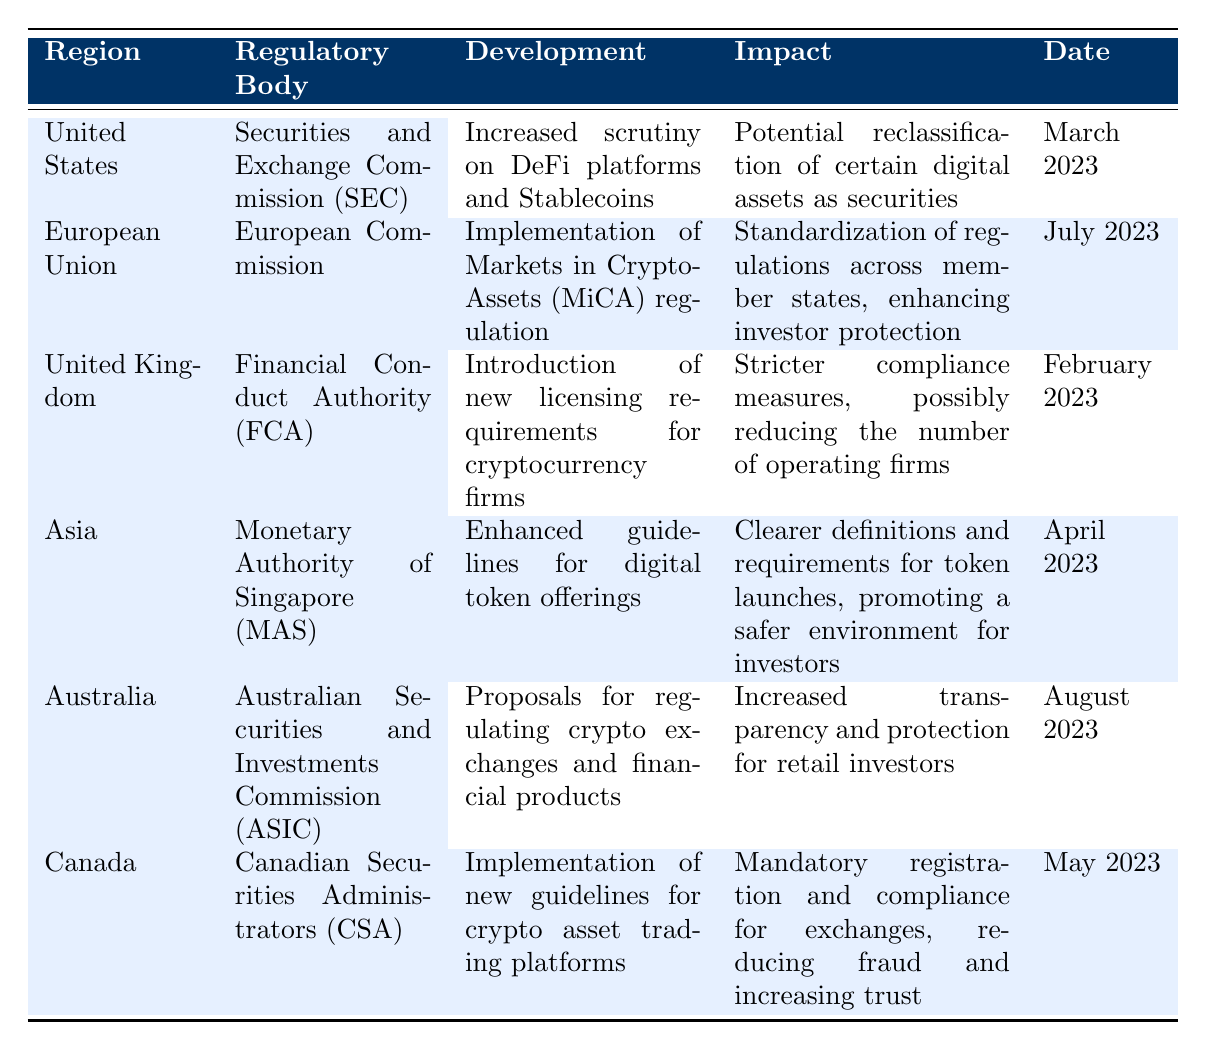What regulatory body is responsible for the development in the United States? The table indicates that the Securities and Exchange Commission (SEC) is the regulatory body responsible for developments in the United States.
Answer: Securities and Exchange Commission (SEC) Which region's regulatory development was focused on the standardization of regulations for investor protection? The table shows that the European Union's development, specifically the implementation of Markets in Crypto-Assets (MiCA) regulation, aims to standardize regulations across member states to enhance investor protection.
Answer: European Union Did the United Kingdom introduce new licensing requirements for cryptocurrency firms? According to the table, the United Kingdom's Financial Conduct Authority (FCA) introduced new licensing requirements for cryptocurrency firms, which implies that this statement is true.
Answer: Yes What is the impact of the May 2023 developments in Canada? The table notes that the development in Canada involves the implementation of new guidelines for crypto asset trading platforms, leading to mandatory registration and compliance for exchanges, which reduces fraud and increases trust among investors.
Answer: Mandatory registration and compliance Which regions introduced regulations in the first half of 2023? The regions that introduced regulations in the first half of 2023 are the United States (March), the United Kingdom (February), and Canada (May). This requires checking the date provided for each region and filtering them by the first half of the year.
Answer: United States, United Kingdom, Canada 